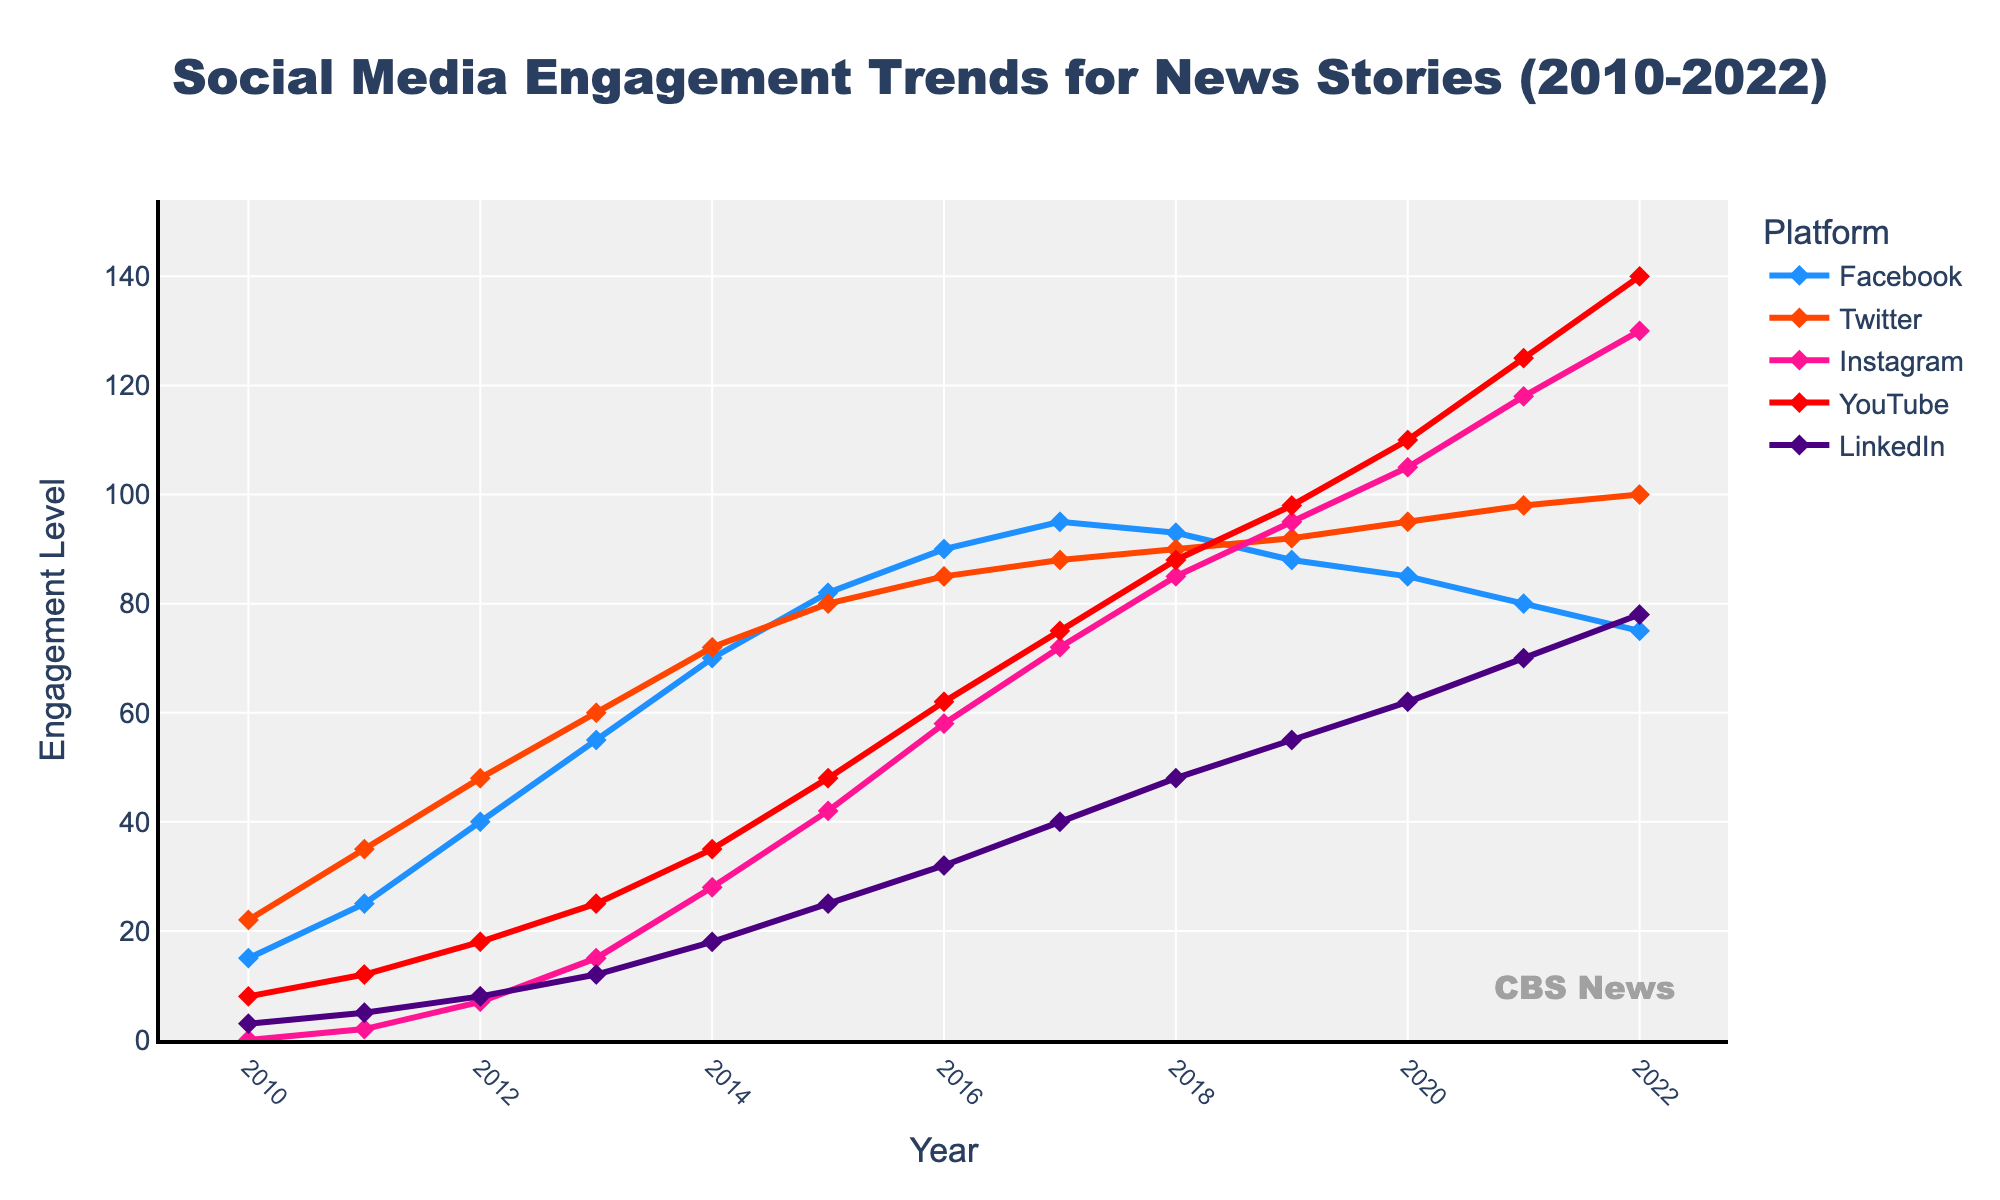what has been the overall trend in Instagram engagement from 2010 to 2022? The Instagram engagement started at 0 in 2010, then consistently increased year by year, reaching 130 in 2022.
Answer: Consistent increase which platform had the highest engagement in 2022? By looking at the final year 2022, YouTube had the highest engagement with 140.
Answer: YouTube which year did Twitter surpass Facebook in engagement? Twitter engagement surpassed Facebook in 2020, where Twitter had 95 and Facebook had 85.
Answer: 2020 what is the average engagement level for LinkedIn across all the years? Adding all LinkedIn engagement values from 2010 to 2022 (3, 5, 8, 12, 18, 25, 32, 40, 48, 55, 62, 70, 78) and dividing by 13 years gives average engagement: (456 / 13) ≈ 35.08.
Answer: ≈ 35.08 how many years did Facebook have a higher engagement than Instagram? Facebook had a higher engagement than Instagram from 2010 to 2015 (6 years).
Answer: 6 years compare the growth of Facebook and YouTube engagement levels from 2010 to 2022. which one grew more? Facebook grew from 15 to 75 (60 units growth), while YouTube grew from 8 to 140 (132 units growth). Therefore, YouTube's growth was higher.
Answer: YouTube what is the sum of engagement levels for all platforms in 2017? Add the values of all platforms in 2017: 95 (Facebook) + 88 (Twitter) + 72 (Instagram) + 75 (YouTube) + 40 (LinkedIn) = 370.
Answer: 370 what was the most significant increase in engagement for a single platform between two consecutive years? For Instagram, from 2014 (28) to 2015 (42), the increase was 14, and from 2020 (105) to 2021 (118), the increase was 13. The most significant increase is 14 for Instagram from 2014 to 2015.
Answer: 14 (Instagram 2014-2015) do all platforms follow a similar trend, or are there any that differ notably? Most platforms show a general increase over time, but Facebook shows a declining trend after peaking in 2017.
Answer: Facebook differs notably 